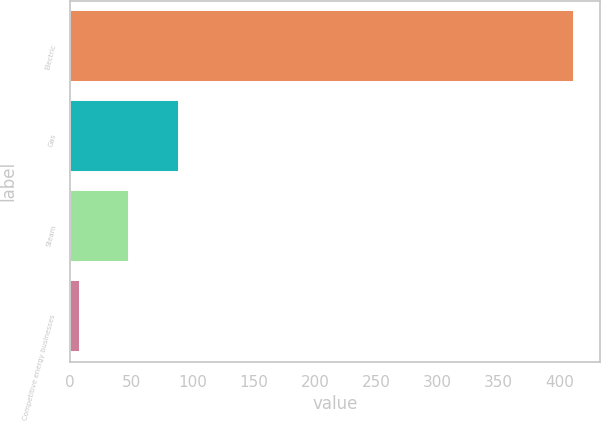<chart> <loc_0><loc_0><loc_500><loc_500><bar_chart><fcel>Electric<fcel>Gas<fcel>Steam<fcel>Competitive energy businesses<nl><fcel>412<fcel>89<fcel>48.4<fcel>8<nl></chart> 